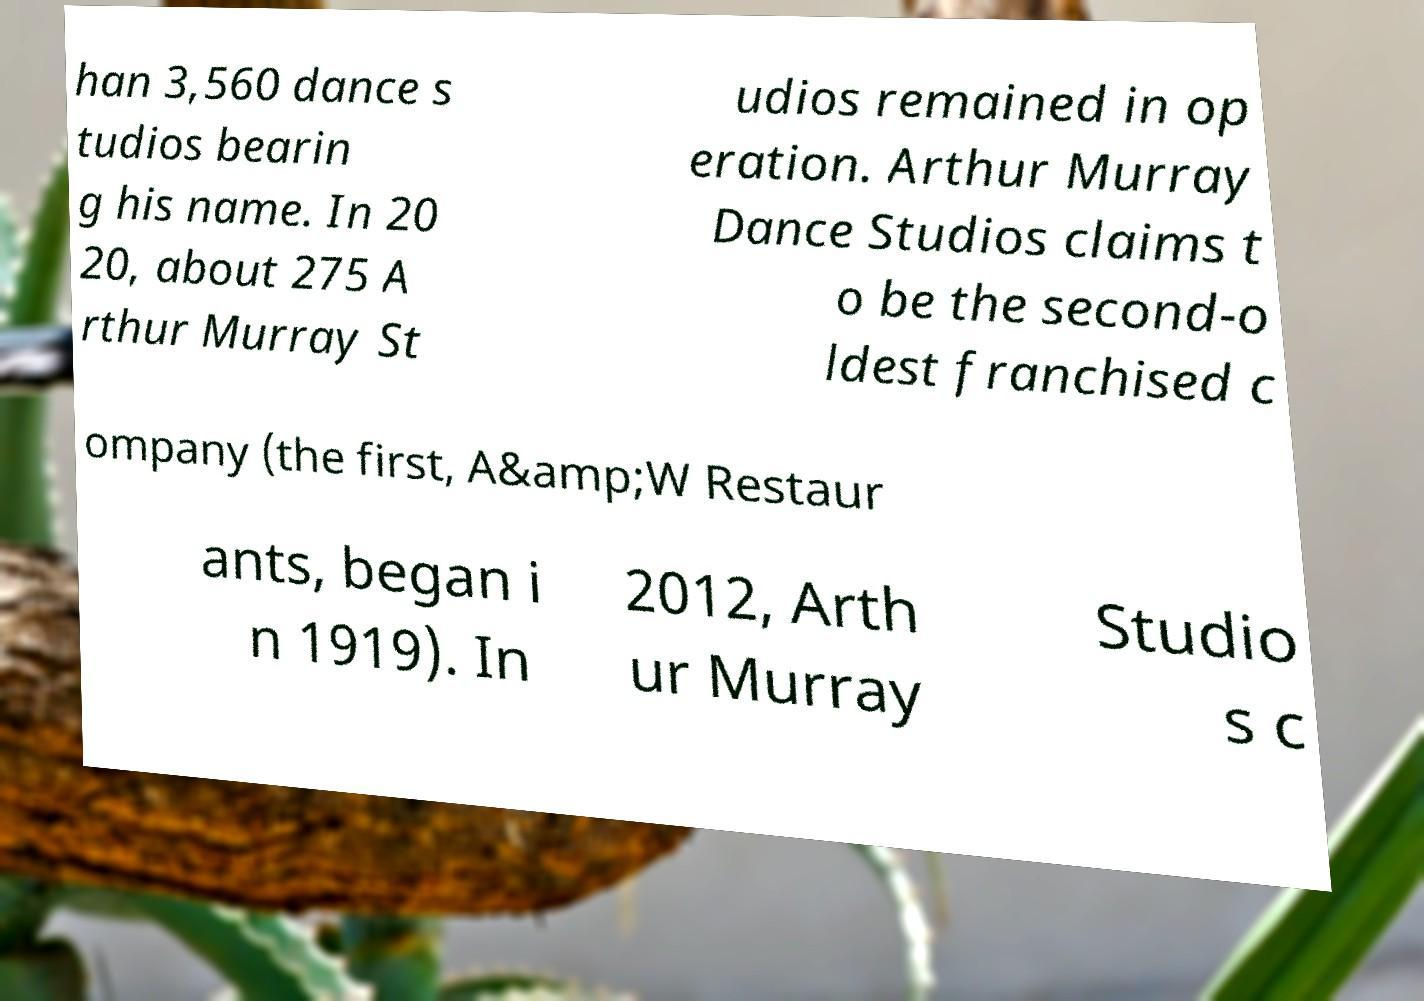For documentation purposes, I need the text within this image transcribed. Could you provide that? han 3,560 dance s tudios bearin g his name. In 20 20, about 275 A rthur Murray St udios remained in op eration. Arthur Murray Dance Studios claims t o be the second-o ldest franchised c ompany (the first, A&amp;W Restaur ants, began i n 1919). In 2012, Arth ur Murray Studio s c 